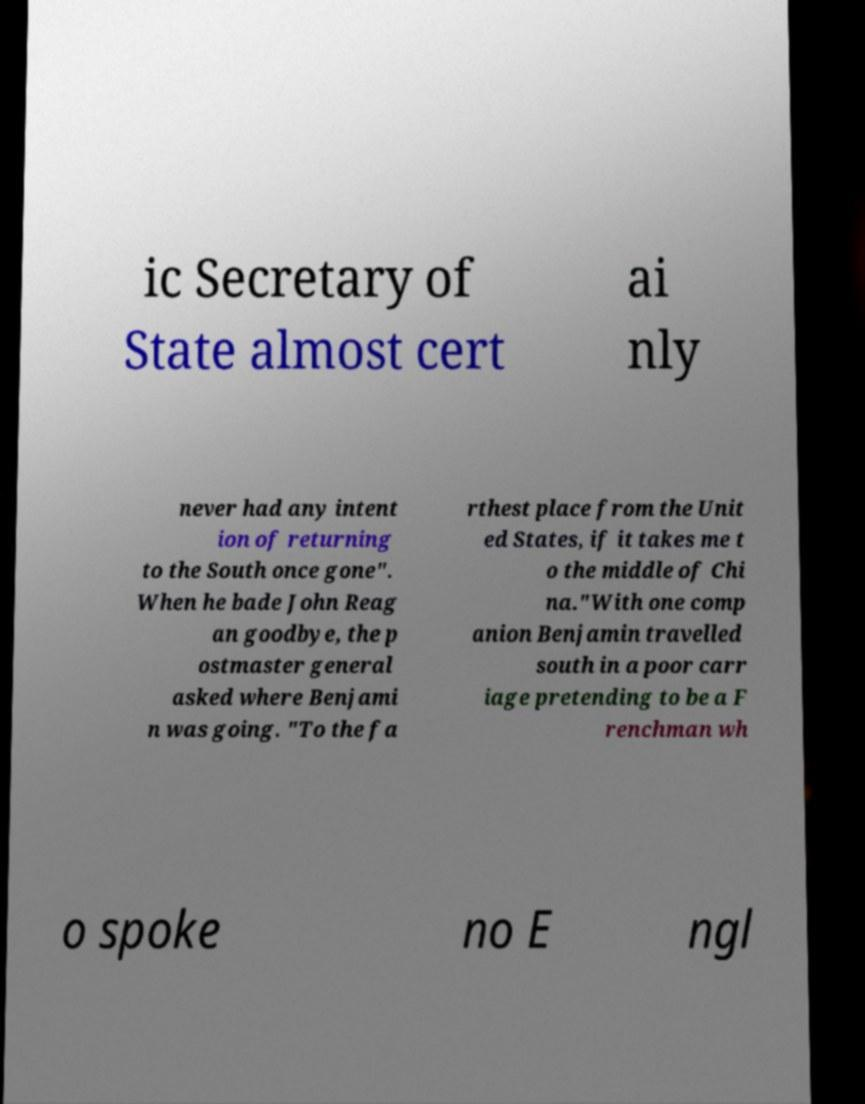For documentation purposes, I need the text within this image transcribed. Could you provide that? ic Secretary of State almost cert ai nly never had any intent ion of returning to the South once gone". When he bade John Reag an goodbye, the p ostmaster general asked where Benjami n was going. "To the fa rthest place from the Unit ed States, if it takes me t o the middle of Chi na."With one comp anion Benjamin travelled south in a poor carr iage pretending to be a F renchman wh o spoke no E ngl 